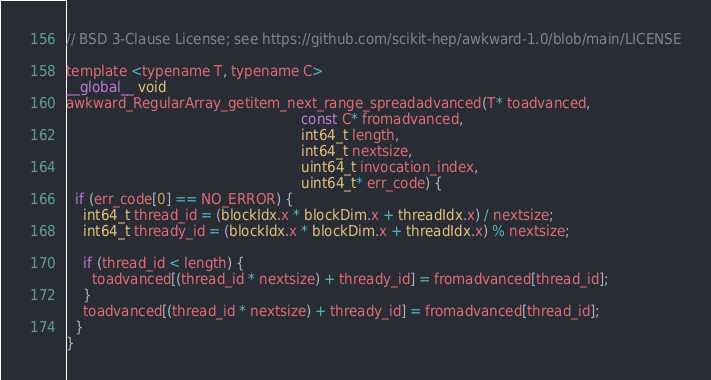Convert code to text. <code><loc_0><loc_0><loc_500><loc_500><_Cuda_>// BSD 3-Clause License; see https://github.com/scikit-hep/awkward-1.0/blob/main/LICENSE

template <typename T, typename C>
__global__ void
awkward_RegularArray_getitem_next_range_spreadadvanced(T* toadvanced,
                                                       const C* fromadvanced,
                                                       int64_t length,
                                                       int64_t nextsize,
                                                       uint64_t invocation_index,
                                                       uint64_t* err_code) {
  if (err_code[0] == NO_ERROR) {
    int64_t thread_id = (blockIdx.x * blockDim.x + threadIdx.x) / nextsize;
    int64_t thready_id = (blockIdx.x * blockDim.x + threadIdx.x) % nextsize;

    if (thread_id < length) {
      toadvanced[(thread_id * nextsize) + thready_id] = fromadvanced[thread_id];
    }
    toadvanced[(thread_id * nextsize) + thready_id] = fromadvanced[thread_id];
  }
}
</code> 